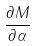<formula> <loc_0><loc_0><loc_500><loc_500>\frac { \partial M } { \partial \alpha }</formula> 